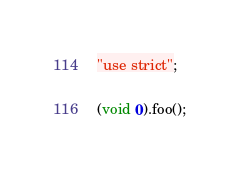<code> <loc_0><loc_0><loc_500><loc_500><_JavaScript_>"use strict";

(void 0).foo();
</code> 